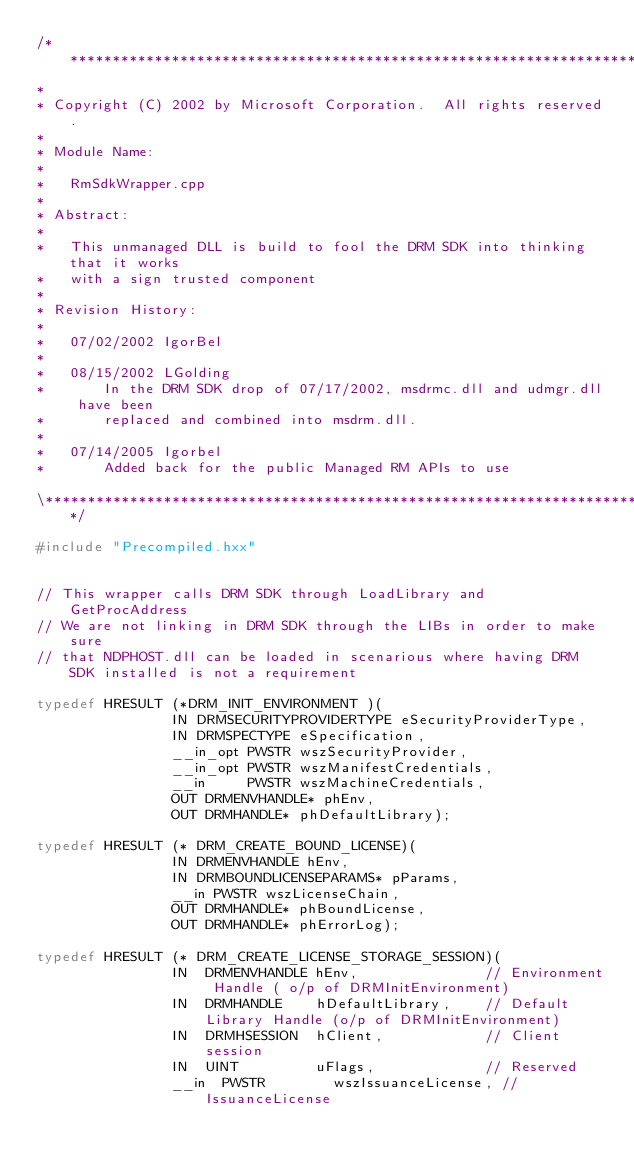<code> <loc_0><loc_0><loc_500><loc_500><_C++_>/**************************************************************************\
*
* Copyright (C) 2002 by Microsoft Corporation.  All rights reserved.
*
* Module Name:
*
*   RmSdkWrapper.cpp
*
* Abstract:  
*
*   This unmanaged DLL is build to fool the DRM SDK into thinking that it works 
*   with a sign trusted component 
*
* Revision History:
*
*   07/02/2002 IgorBel
*
*   08/15/2002 LGolding
*       In the DRM SDK drop of 07/17/2002, msdrmc.dll and udmgr.dll have been
*       replaced and combined into msdrm.dll.
*
*   07/14/2005 Igorbel 
*       Added back for the public Managed RM APIs to use 

\**************************************************************************/

#include "Precompiled.hxx"


// This wrapper calls DRM SDK through LoadLibrary and GetProcAddress
// We are not linking in DRM SDK through the LIBs in order to make sure 
// that NDPHOST.dll can be loaded in scenarious where having DRM SDK installed is not a requirement

typedef HRESULT (*DRM_INIT_ENVIRONMENT )(
								IN DRMSECURITYPROVIDERTYPE eSecurityProviderType,
								IN DRMSPECTYPE eSpecification,
								__in_opt PWSTR wszSecurityProvider,
								__in_opt PWSTR wszManifestCredentials,
								__in     PWSTR wszMachineCredentials,
								OUT DRMENVHANDLE* phEnv,
								OUT DRMHANDLE* phDefaultLibrary);

typedef HRESULT (* DRM_CREATE_BOUND_LICENSE)(
								IN DRMENVHANDLE hEnv,
								IN DRMBOUNDLICENSEPARAMS* pParams,
								__in PWSTR wszLicenseChain,
								OUT DRMHANDLE* phBoundLicense,
								OUT DRMHANDLE* phErrorLog);

typedef HRESULT (* DRM_CREATE_LICENSE_STORAGE_SESSION)(
								IN  DRMENVHANDLE hEnv,               // Environment Handle ( o/p of DRMInitEnvironment)
								IN  DRMHANDLE    hDefaultLibrary,    // Default Library Handle (o/p of DRMInitEnvironment)
								IN  DRMHSESSION  hClient,            // Client session
								IN  UINT         uFlags,             // Reserved
								__in  PWSTR        wszIssuanceLicense, // IssuanceLicense</code> 